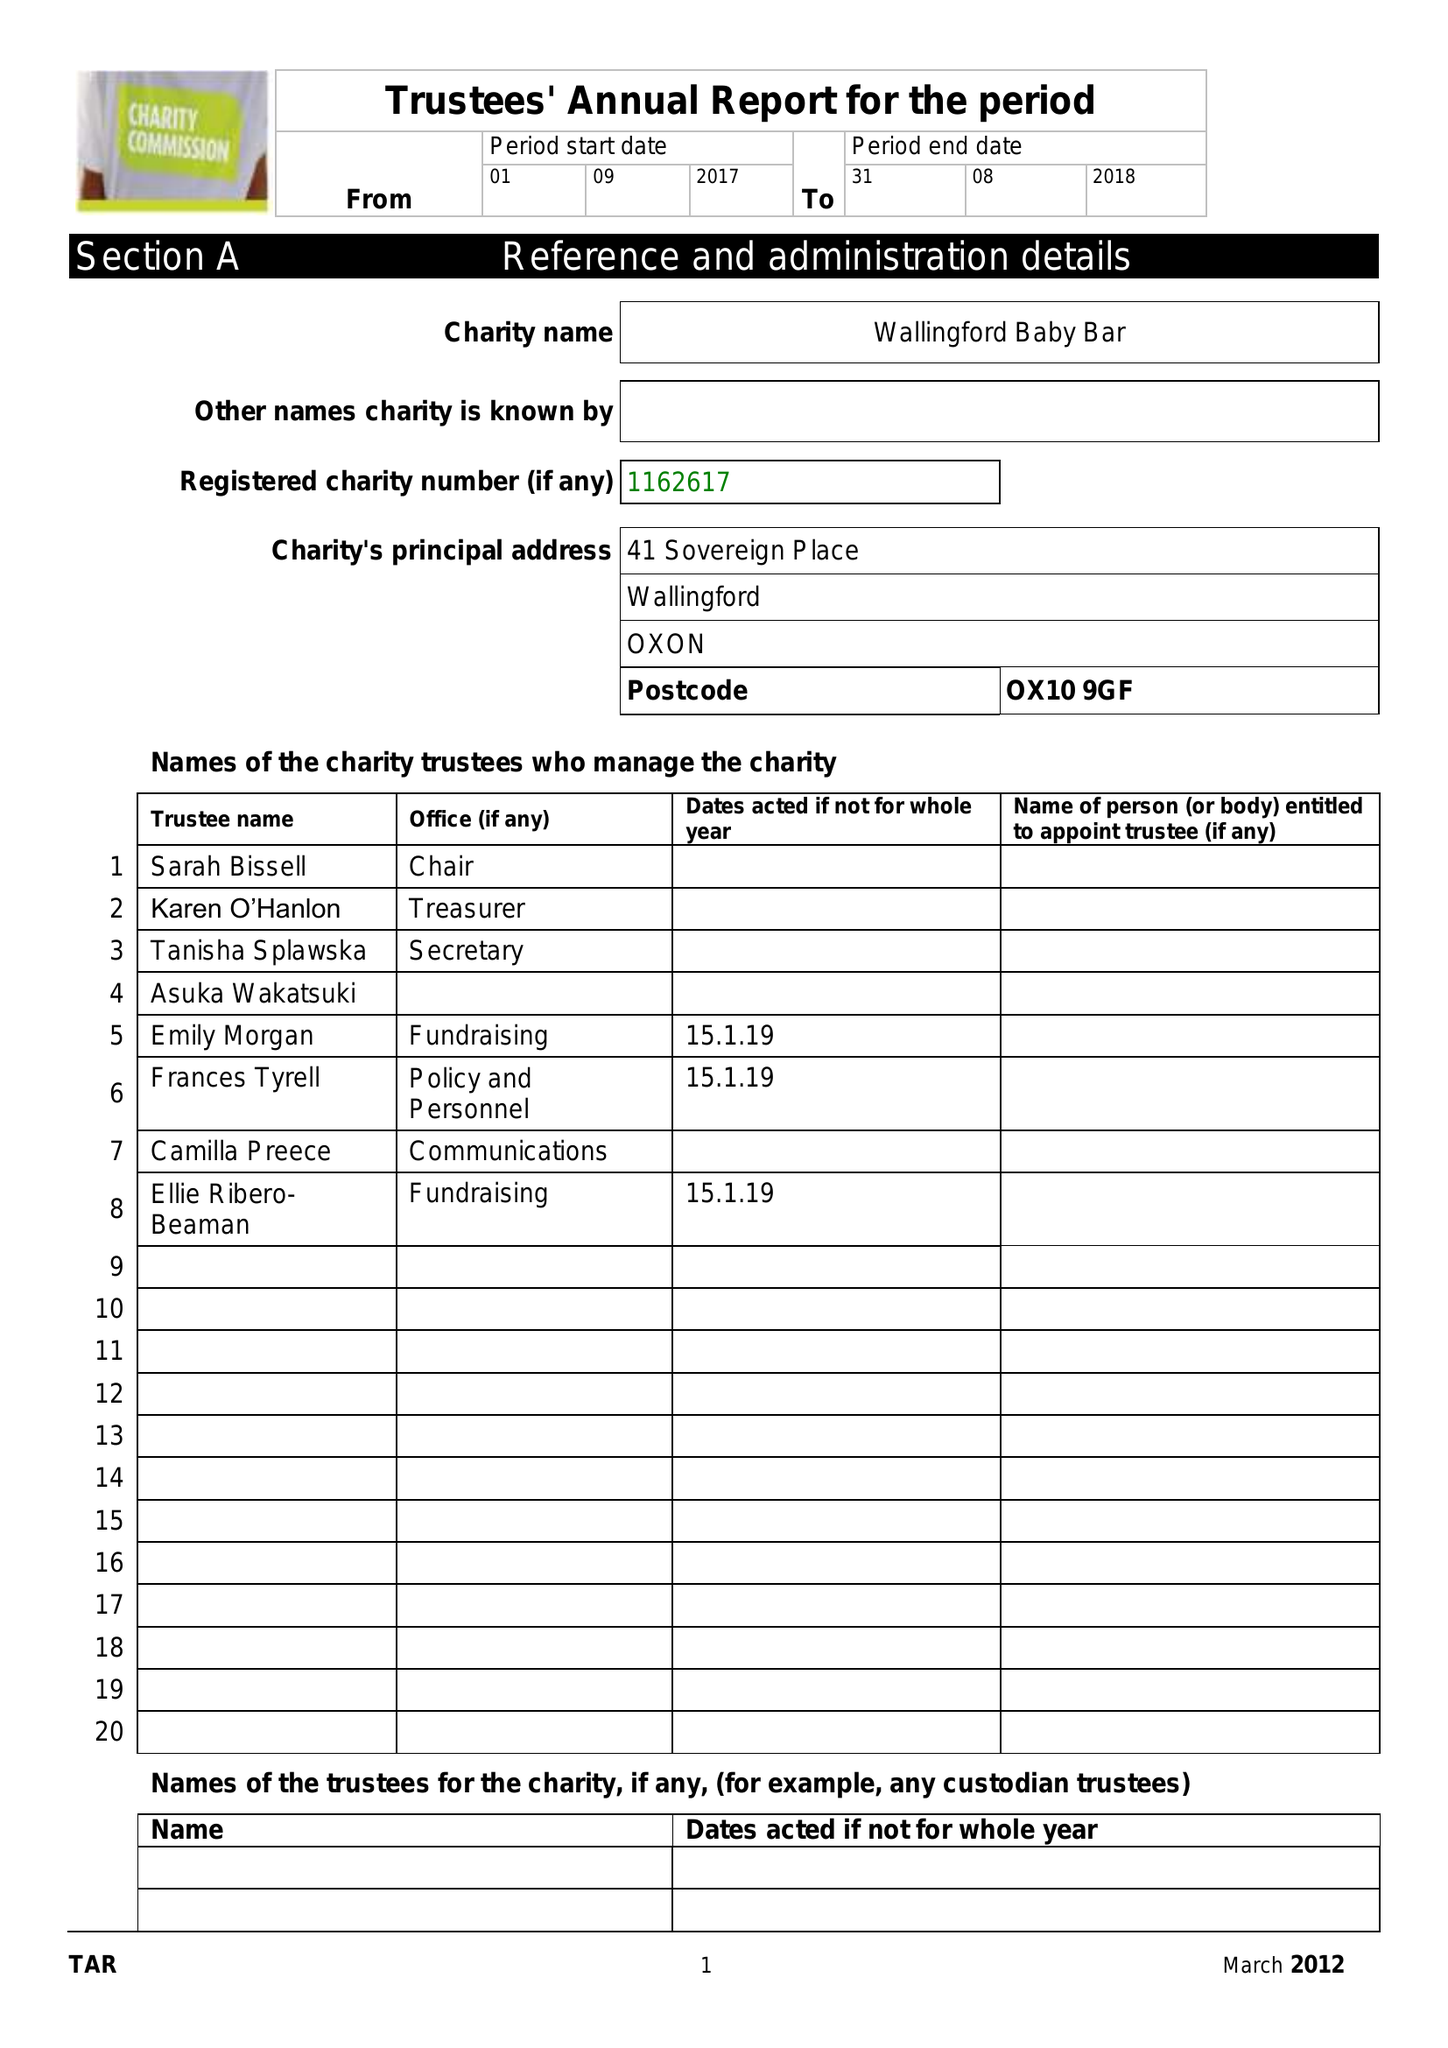What is the value for the report_date?
Answer the question using a single word or phrase. 2018-08-31 